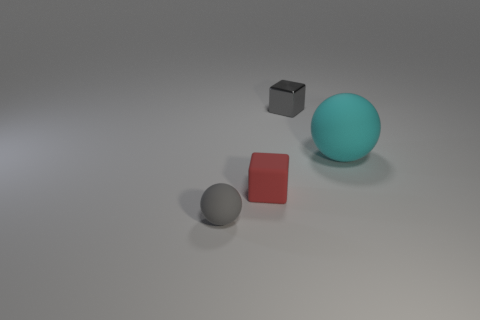Add 2 metal blocks. How many objects exist? 6 Subtract all gray cubes. How many cubes are left? 1 Subtract all brown cylinders. How many green cubes are left? 0 Subtract 0 cyan cubes. How many objects are left? 4 Subtract 2 spheres. How many spheres are left? 0 Subtract all red cubes. Subtract all cyan cylinders. How many cubes are left? 1 Subtract all gray matte balls. Subtract all gray metal things. How many objects are left? 2 Add 3 gray rubber balls. How many gray rubber balls are left? 4 Add 2 red rubber cubes. How many red rubber cubes exist? 3 